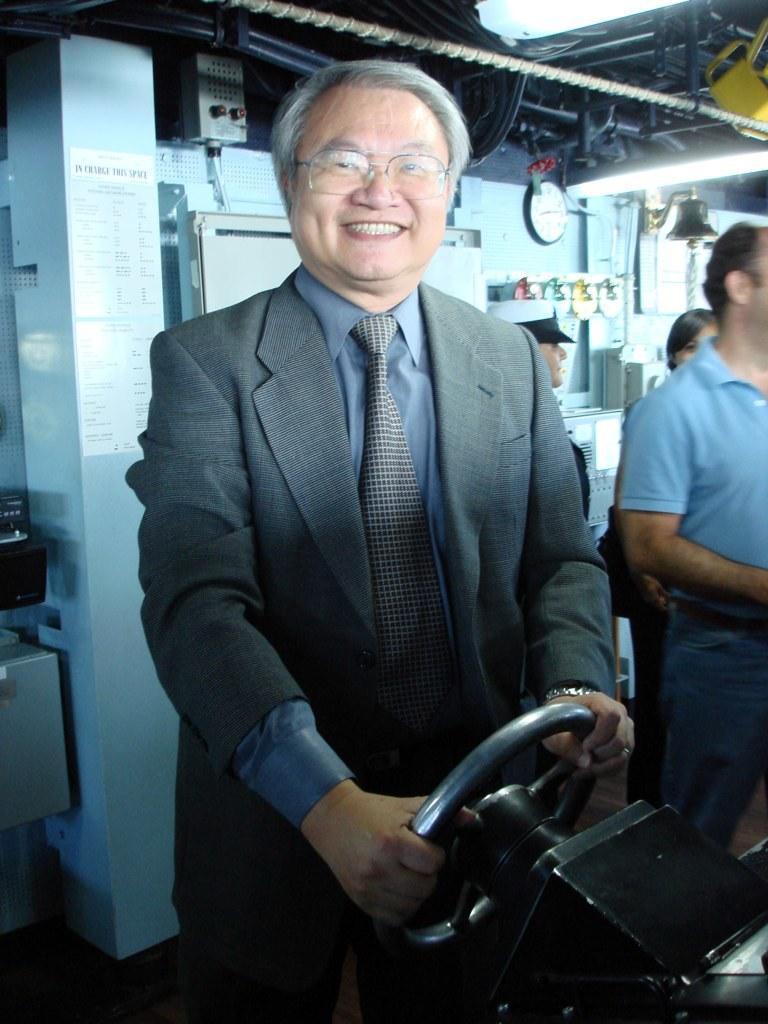Please provide a concise description of this image. In this picture we can see a person, he is wearing a spectacles and holding a steering and in the background we can see people, clock and some objects. 